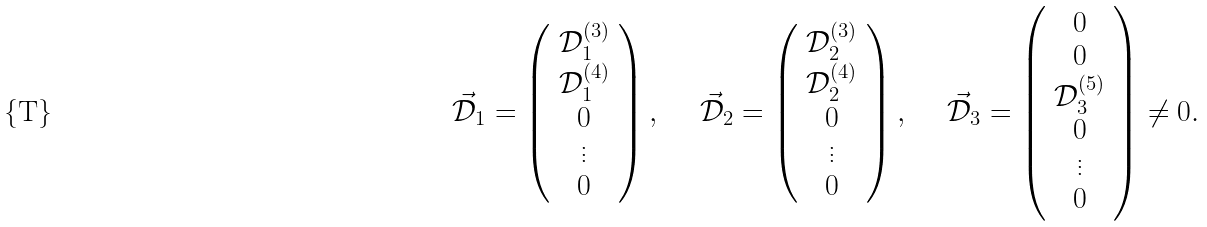<formula> <loc_0><loc_0><loc_500><loc_500>\vec { \mathcal { D } } _ { 1 } = \left ( \begin{array} { c } \mathcal { D } _ { 1 } ^ { ( 3 ) } \\ \mathcal { D } _ { 1 } ^ { ( 4 ) } \\ 0 \\ \vdots \\ 0 \end{array} \right ) , \quad \ \vec { \mathcal { D } } _ { 2 } = \left ( \begin{array} { c } \mathcal { D } _ { 2 } ^ { ( 3 ) } \\ \mathcal { D } _ { 2 } ^ { ( 4 ) } \\ 0 \\ \vdots \\ 0 \end{array} \right ) , \quad \ \vec { \mathcal { D } } _ { 3 } = \left ( \begin{array} { c } 0 \\ 0 \\ \mathcal { D } _ { 3 } ^ { ( 5 ) } \\ 0 \\ \vdots \\ 0 \end{array} \right ) \neq 0 .</formula> 